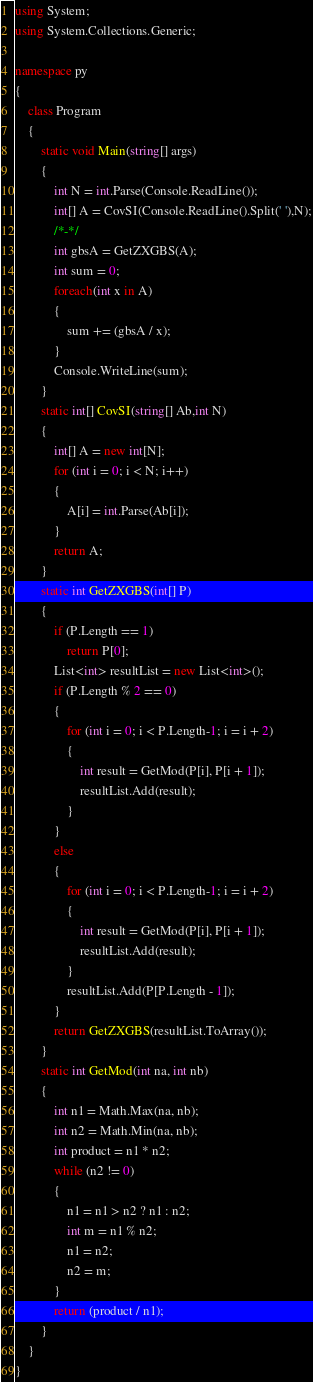<code> <loc_0><loc_0><loc_500><loc_500><_C#_>using System;
using System.Collections.Generic;

namespace py
{
    class Program
    {
        static void Main(string[] args)
        {
            int N = int.Parse(Console.ReadLine());
            int[] A = CovSI(Console.ReadLine().Split(' '),N);
            /*-*/
            int gbsA = GetZXGBS(A);
            int sum = 0;
            foreach(int x in A)
            {
                sum += (gbsA / x);
            }
            Console.WriteLine(sum);
        }
        static int[] CovSI(string[] Ab,int N)
        {
            int[] A = new int[N];
            for (int i = 0; i < N; i++)
            {
                A[i] = int.Parse(Ab[i]);
            }
            return A;
        }
        static int GetZXGBS(int[] P)
        {
            if (P.Length == 1)
                return P[0];
            List<int> resultList = new List<int>();
            if (P.Length % 2 == 0)
            {
                for (int i = 0; i < P.Length-1; i = i + 2)
                {
                    int result = GetMod(P[i], P[i + 1]);
                    resultList.Add(result);
                }
            }
            else
            {
                for (int i = 0; i < P.Length-1; i = i + 2)
                {
                    int result = GetMod(P[i], P[i + 1]);
                    resultList.Add(result);
                }
                resultList.Add(P[P.Length - 1]);
            }
            return GetZXGBS(resultList.ToArray());
        }
        static int GetMod(int na, int nb)
        {
            int n1 = Math.Max(na, nb);
            int n2 = Math.Min(na, nb);
            int product = n1 * n2;
            while (n2 != 0)
            {
                n1 = n1 > n2 ? n1 : n2;
                int m = n1 % n2;
                n1 = n2;
                n2 = m;
            }
            return (product / n1);
        }
    }
}</code> 